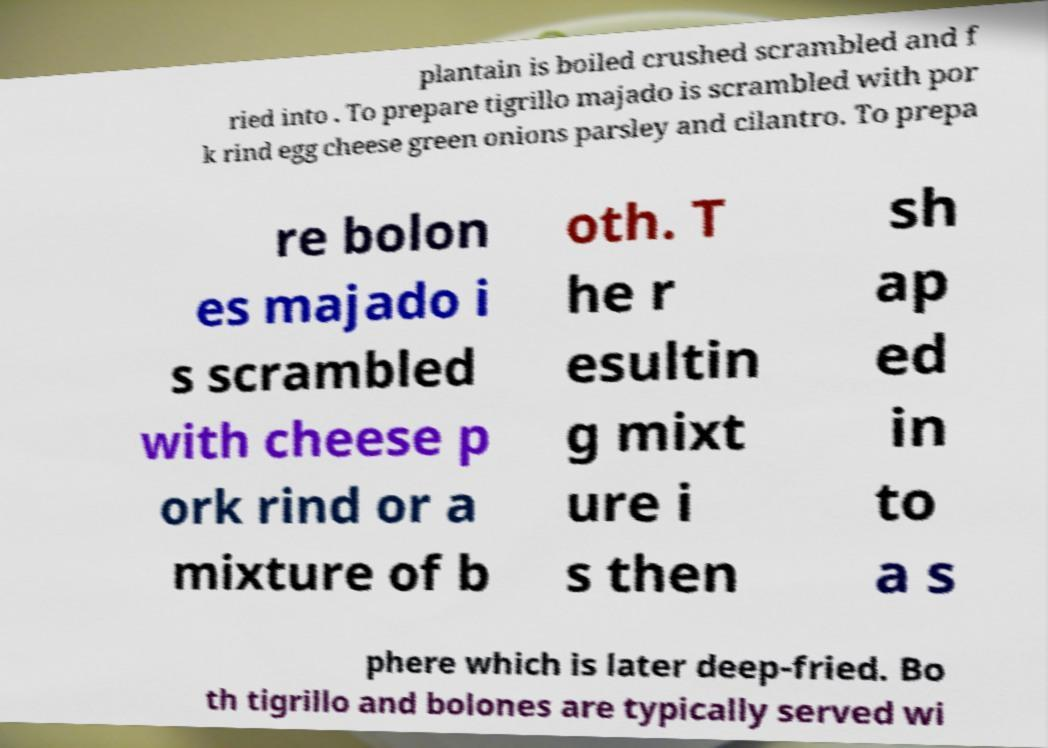Could you extract and type out the text from this image? plantain is boiled crushed scrambled and f ried into . To prepare tigrillo majado is scrambled with por k rind egg cheese green onions parsley and cilantro. To prepa re bolon es majado i s scrambled with cheese p ork rind or a mixture of b oth. T he r esultin g mixt ure i s then sh ap ed in to a s phere which is later deep-fried. Bo th tigrillo and bolones are typically served wi 